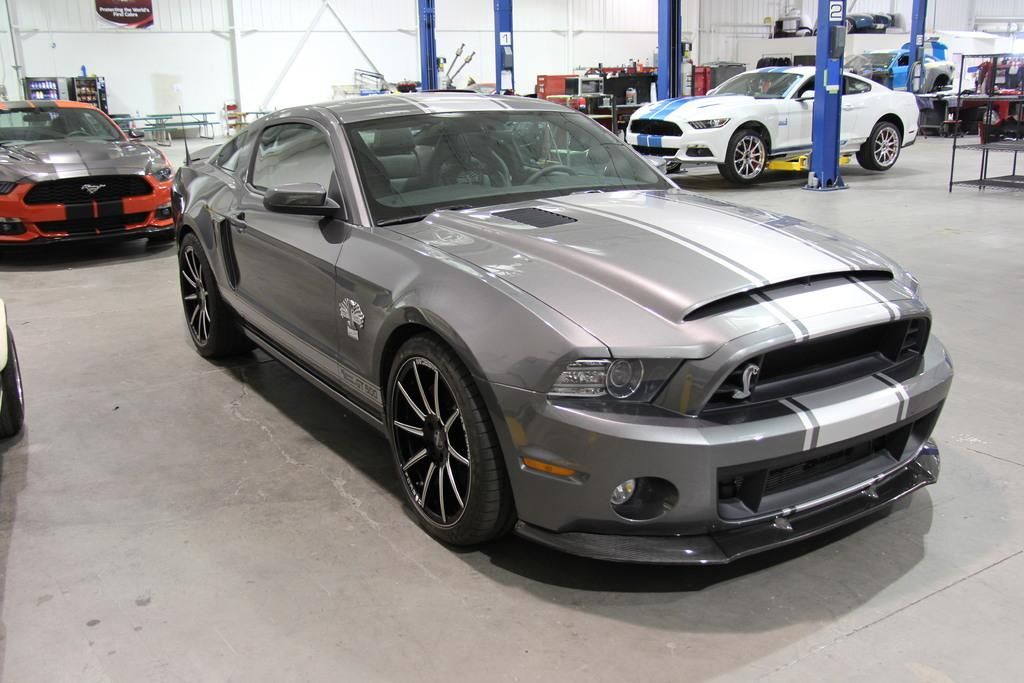What type of view is shown in the image? The image is an inside view. How many cars are on the floor in the image? There are four cars on the floor in the image. What can be seen in the background of the image? There are machines and pillars visible in the background. Are the machines placed on the floor or elevated? The machines are placed on the floor in the image. What type of teeth can be seen in the image? There are no teeth visible in the image. Is there anyone reading a book in the image? There is no one reading a book in the image. 